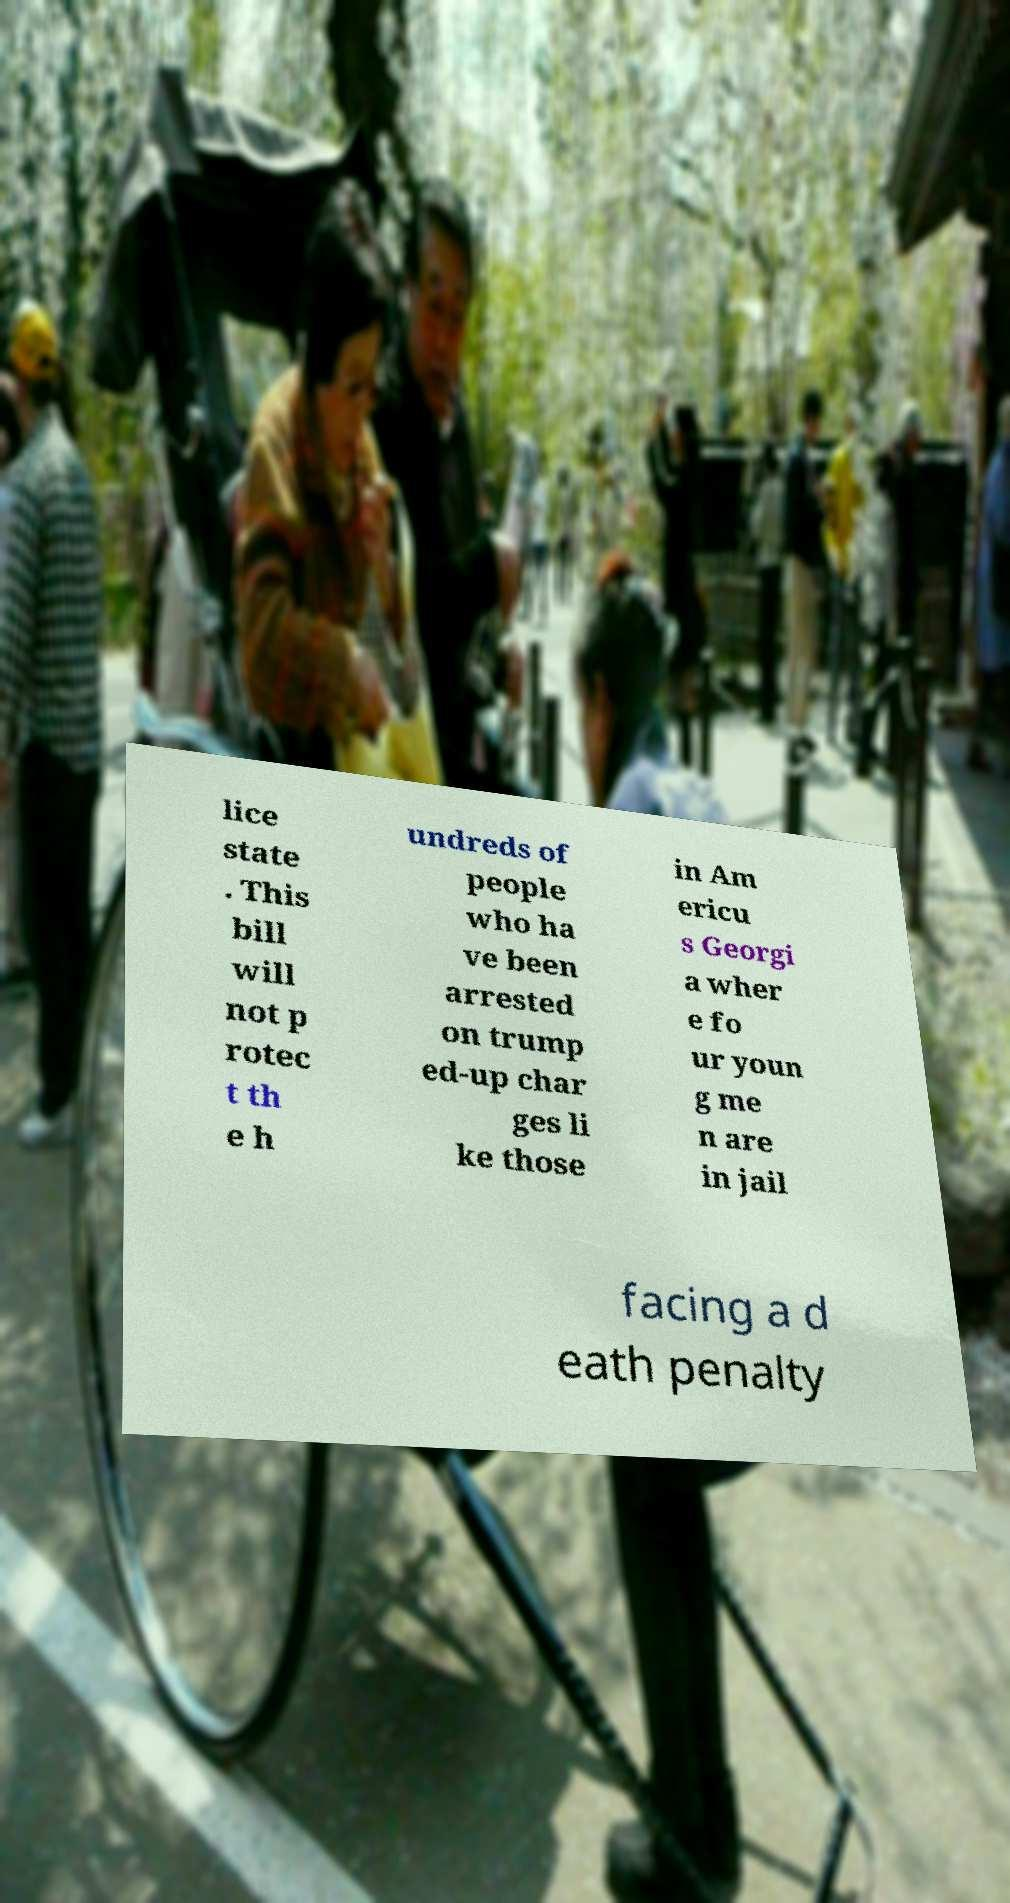Can you accurately transcribe the text from the provided image for me? lice state . This bill will not p rotec t th e h undreds of people who ha ve been arrested on trump ed-up char ges li ke those in Am ericu s Georgi a wher e fo ur youn g me n are in jail facing a d eath penalty 